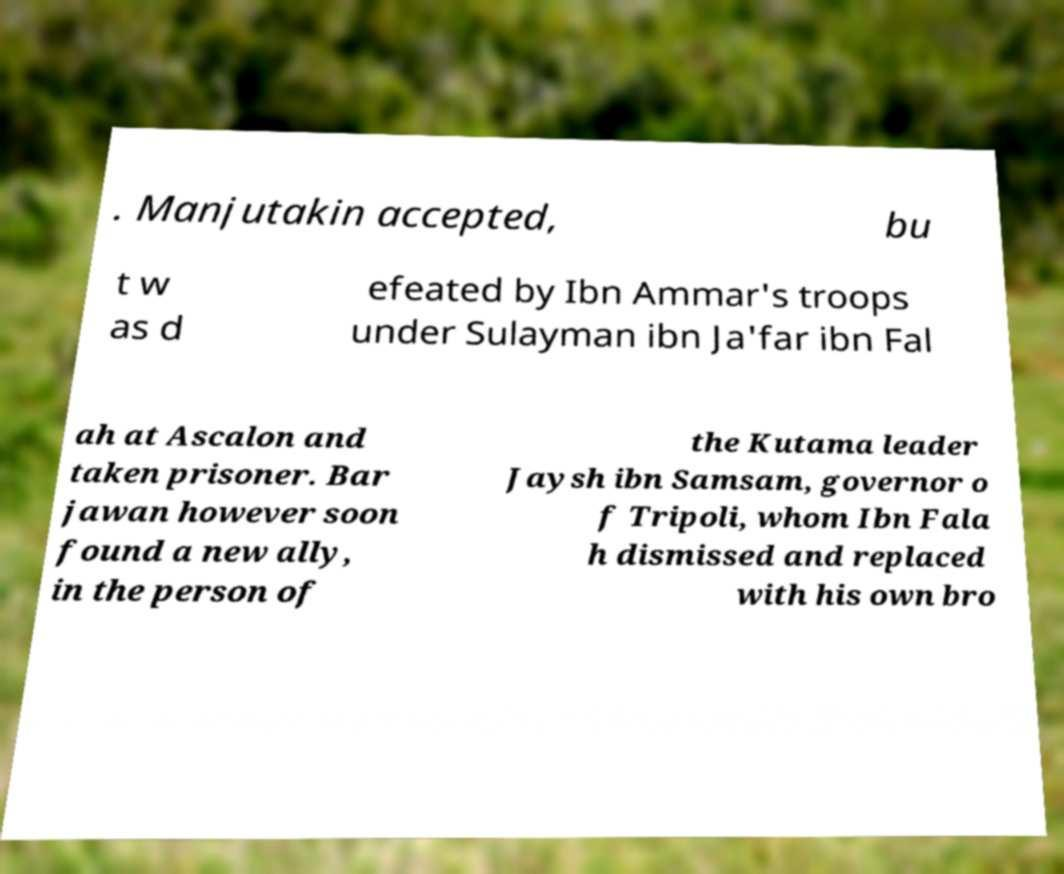I need the written content from this picture converted into text. Can you do that? . Manjutakin accepted, bu t w as d efeated by Ibn Ammar's troops under Sulayman ibn Ja'far ibn Fal ah at Ascalon and taken prisoner. Bar jawan however soon found a new ally, in the person of the Kutama leader Jaysh ibn Samsam, governor o f Tripoli, whom Ibn Fala h dismissed and replaced with his own bro 